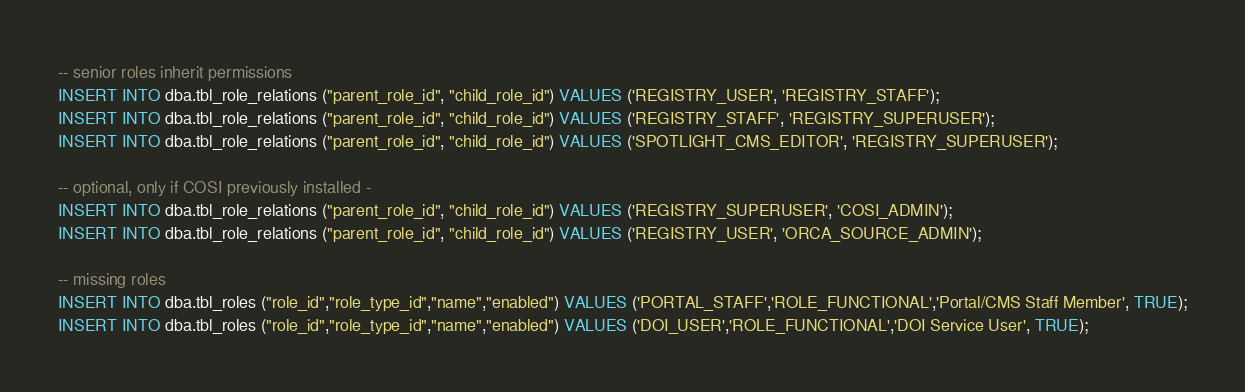<code> <loc_0><loc_0><loc_500><loc_500><_SQL_>-- senior roles inherit permissions
INSERT INTO dba.tbl_role_relations ("parent_role_id", "child_role_id") VALUES ('REGISTRY_USER', 'REGISTRY_STAFF');
INSERT INTO dba.tbl_role_relations ("parent_role_id", "child_role_id") VALUES ('REGISTRY_STAFF', 'REGISTRY_SUPERUSER');
INSERT INTO dba.tbl_role_relations ("parent_role_id", "child_role_id") VALUES ('SPOTLIGHT_CMS_EDITOR', 'REGISTRY_SUPERUSER');

-- optional, only if COSI previously installed -
INSERT INTO dba.tbl_role_relations ("parent_role_id", "child_role_id") VALUES ('REGISTRY_SUPERUSER', 'COSI_ADMIN');
INSERT INTO dba.tbl_role_relations ("parent_role_id", "child_role_id") VALUES ('REGISTRY_USER', 'ORCA_SOURCE_ADMIN');

-- missing roles
INSERT INTO dba.tbl_roles ("role_id","role_type_id","name","enabled") VALUES ('PORTAL_STAFF','ROLE_FUNCTIONAL','Portal/CMS Staff Member', TRUE);
INSERT INTO dba.tbl_roles ("role_id","role_type_id","name","enabled") VALUES ('DOI_USER','ROLE_FUNCTIONAL','DOI Service User', TRUE);</code> 